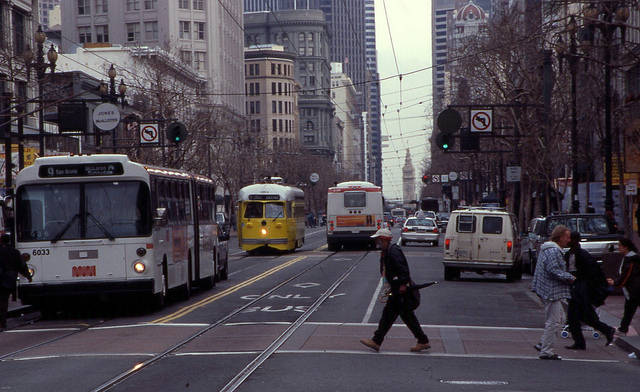<image>Was this photo taken in the U.S.? I am not sure. The location of the photo is ambiguous. Was this photo taken in the U.S.? I don't know if this photo was taken in the U.S. It is unclear. 